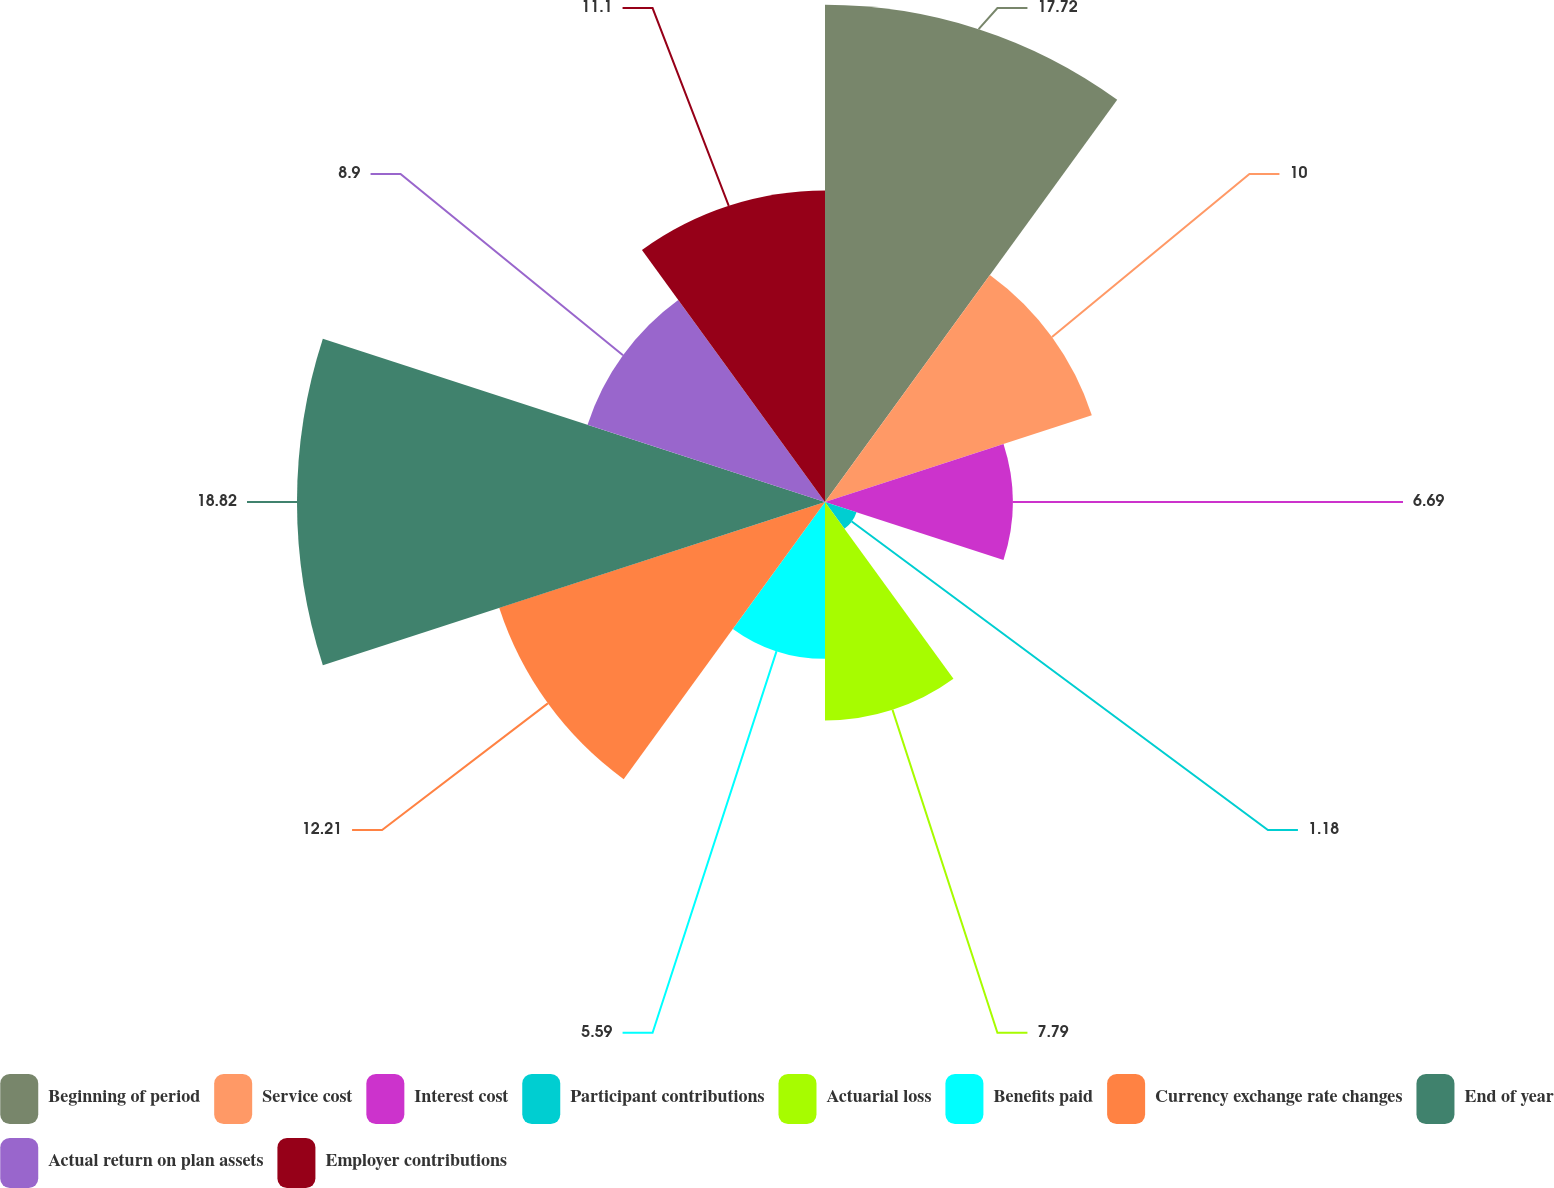Convert chart. <chart><loc_0><loc_0><loc_500><loc_500><pie_chart><fcel>Beginning of period<fcel>Service cost<fcel>Interest cost<fcel>Participant contributions<fcel>Actuarial loss<fcel>Benefits paid<fcel>Currency exchange rate changes<fcel>End of year<fcel>Actual return on plan assets<fcel>Employer contributions<nl><fcel>17.72%<fcel>10.0%<fcel>6.69%<fcel>1.18%<fcel>7.79%<fcel>5.59%<fcel>12.21%<fcel>18.82%<fcel>8.9%<fcel>11.1%<nl></chart> 